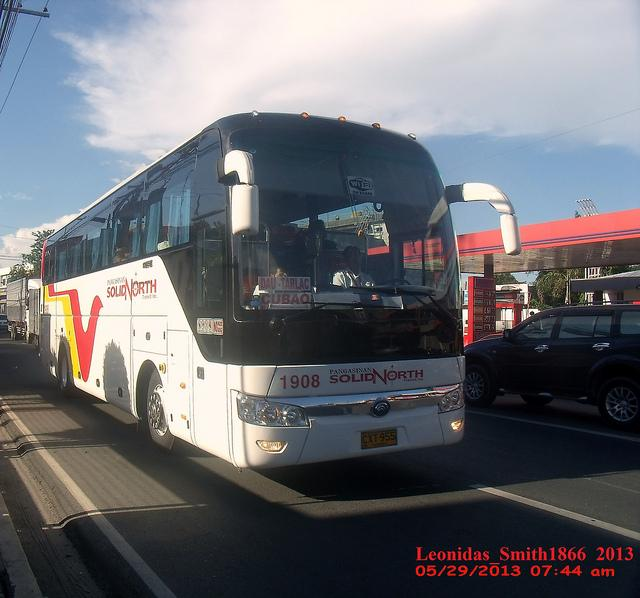What is the red building to the right of the bus used for?

Choices:
A) convenience store
B) gas station
C) auto mechanic
D) grocery store gas station 